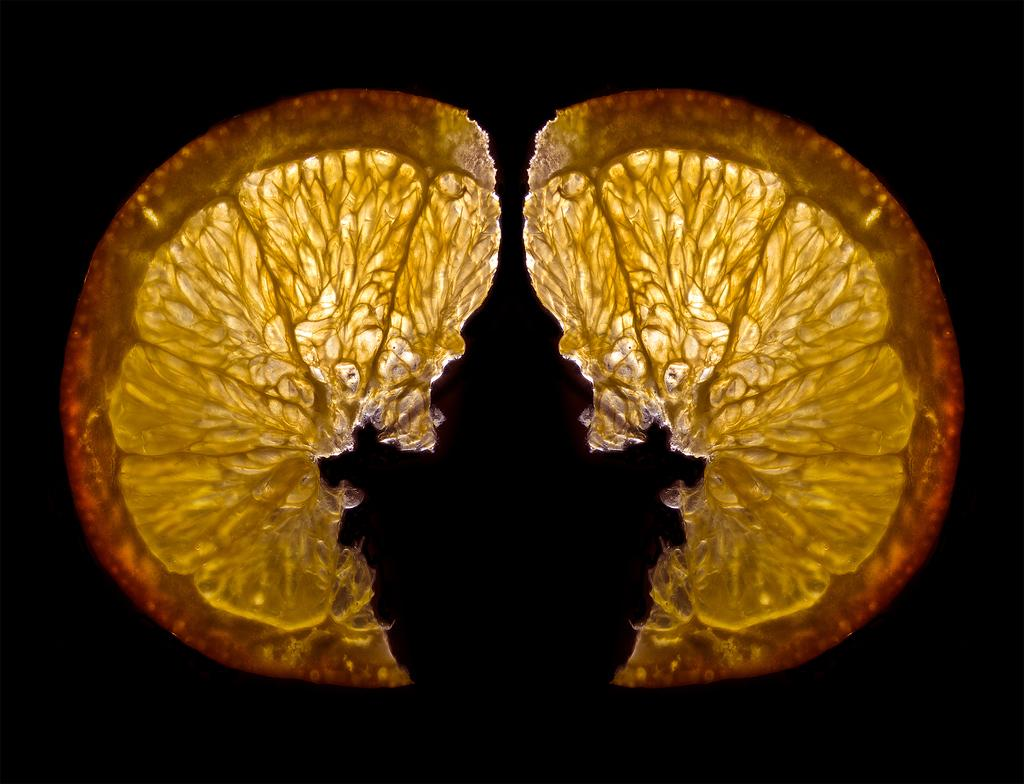What is the main subject of the image? The main subject of the image is an orange. Can you describe the colors of the orange? The orange has yellow and orange colors. What color is the background of the image? The background of the image is black. Can you tell me how many strangers are standing near the trees in the image? There are no strangers or trees present in the image; it features an orange with a black background. What type of advice does the father give to the child in the image? There is no father or child present in the image; it features an orange with a black background. 